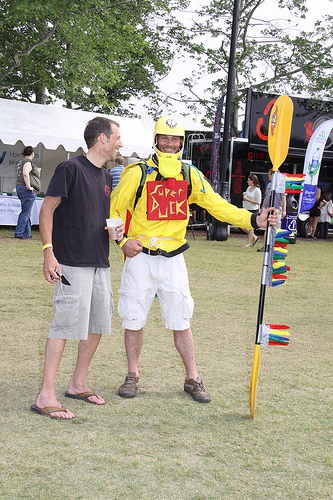<image>
Is the sign on the shirt? Yes. Looking at the image, I can see the sign is positioned on top of the shirt, with the shirt providing support. 